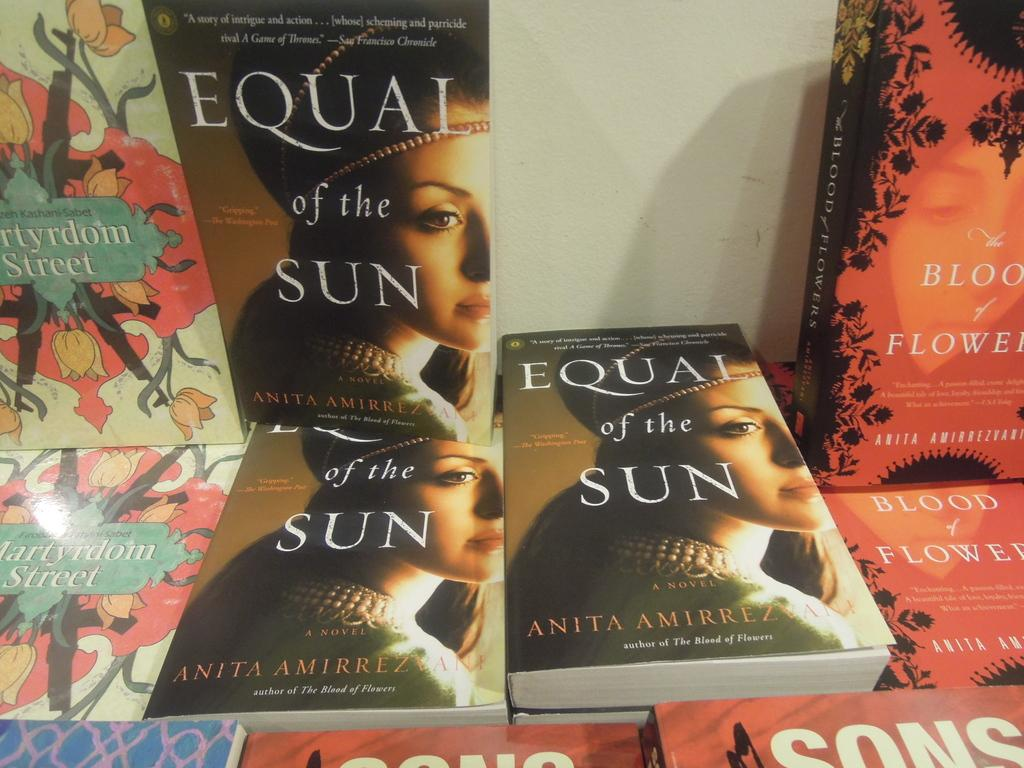What type of object is in the image? There is a storybook in the image. Where is the storybook located in relation to other objects? The storybook is near a wall. What is the title of the storybook? The storybook has the name "Equal of the Sun." Are there any other books in the image? Yes, there is another book in the image. What is depicted on the cover of the other book? The other book has blood and flowers on its cover. Can you describe the snail crawling on the spine of the storybook? There is no snail present on the storybook in the image. 